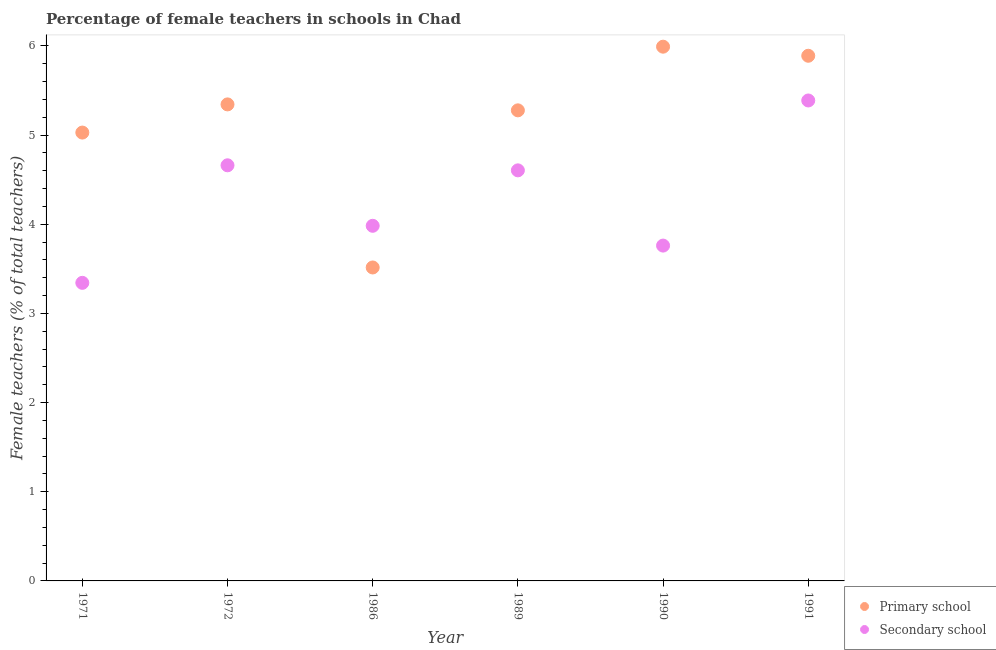How many different coloured dotlines are there?
Provide a succinct answer. 2. Is the number of dotlines equal to the number of legend labels?
Ensure brevity in your answer.  Yes. What is the percentage of female teachers in secondary schools in 1989?
Offer a terse response. 4.6. Across all years, what is the maximum percentage of female teachers in secondary schools?
Make the answer very short. 5.39. Across all years, what is the minimum percentage of female teachers in primary schools?
Provide a short and direct response. 3.52. What is the total percentage of female teachers in primary schools in the graph?
Your answer should be very brief. 31.05. What is the difference between the percentage of female teachers in primary schools in 1986 and that in 1991?
Provide a succinct answer. -2.37. What is the difference between the percentage of female teachers in primary schools in 1990 and the percentage of female teachers in secondary schools in 1986?
Offer a very short reply. 2.01. What is the average percentage of female teachers in primary schools per year?
Ensure brevity in your answer.  5.17. In the year 1991, what is the difference between the percentage of female teachers in primary schools and percentage of female teachers in secondary schools?
Your answer should be very brief. 0.5. What is the ratio of the percentage of female teachers in secondary schools in 1986 to that in 1989?
Provide a short and direct response. 0.86. Is the difference between the percentage of female teachers in primary schools in 1989 and 1990 greater than the difference between the percentage of female teachers in secondary schools in 1989 and 1990?
Keep it short and to the point. No. What is the difference between the highest and the second highest percentage of female teachers in secondary schools?
Offer a terse response. 0.73. What is the difference between the highest and the lowest percentage of female teachers in secondary schools?
Offer a terse response. 2.05. In how many years, is the percentage of female teachers in secondary schools greater than the average percentage of female teachers in secondary schools taken over all years?
Make the answer very short. 3. Is the percentage of female teachers in primary schools strictly greater than the percentage of female teachers in secondary schools over the years?
Offer a terse response. No. Is the percentage of female teachers in secondary schools strictly less than the percentage of female teachers in primary schools over the years?
Offer a very short reply. No. How many years are there in the graph?
Your answer should be compact. 6. What is the difference between two consecutive major ticks on the Y-axis?
Your response must be concise. 1. Does the graph contain any zero values?
Give a very brief answer. No. Does the graph contain grids?
Offer a very short reply. No. How are the legend labels stacked?
Your answer should be very brief. Vertical. What is the title of the graph?
Make the answer very short. Percentage of female teachers in schools in Chad. Does "Secondary school" appear as one of the legend labels in the graph?
Offer a very short reply. Yes. What is the label or title of the X-axis?
Give a very brief answer. Year. What is the label or title of the Y-axis?
Provide a succinct answer. Female teachers (% of total teachers). What is the Female teachers (% of total teachers) in Primary school in 1971?
Provide a succinct answer. 5.03. What is the Female teachers (% of total teachers) in Secondary school in 1971?
Offer a terse response. 3.34. What is the Female teachers (% of total teachers) of Primary school in 1972?
Keep it short and to the point. 5.34. What is the Female teachers (% of total teachers) of Secondary school in 1972?
Your response must be concise. 4.66. What is the Female teachers (% of total teachers) in Primary school in 1986?
Your answer should be very brief. 3.52. What is the Female teachers (% of total teachers) in Secondary school in 1986?
Make the answer very short. 3.98. What is the Female teachers (% of total teachers) of Primary school in 1989?
Keep it short and to the point. 5.28. What is the Female teachers (% of total teachers) of Secondary school in 1989?
Offer a very short reply. 4.6. What is the Female teachers (% of total teachers) of Primary school in 1990?
Offer a terse response. 5.99. What is the Female teachers (% of total teachers) of Secondary school in 1990?
Provide a short and direct response. 3.76. What is the Female teachers (% of total teachers) in Primary school in 1991?
Offer a very short reply. 5.89. What is the Female teachers (% of total teachers) in Secondary school in 1991?
Provide a succinct answer. 5.39. Across all years, what is the maximum Female teachers (% of total teachers) in Primary school?
Keep it short and to the point. 5.99. Across all years, what is the maximum Female teachers (% of total teachers) of Secondary school?
Ensure brevity in your answer.  5.39. Across all years, what is the minimum Female teachers (% of total teachers) in Primary school?
Ensure brevity in your answer.  3.52. Across all years, what is the minimum Female teachers (% of total teachers) of Secondary school?
Keep it short and to the point. 3.34. What is the total Female teachers (% of total teachers) in Primary school in the graph?
Your answer should be compact. 31.05. What is the total Female teachers (% of total teachers) in Secondary school in the graph?
Your answer should be compact. 25.74. What is the difference between the Female teachers (% of total teachers) in Primary school in 1971 and that in 1972?
Offer a very short reply. -0.32. What is the difference between the Female teachers (% of total teachers) in Secondary school in 1971 and that in 1972?
Offer a terse response. -1.32. What is the difference between the Female teachers (% of total teachers) in Primary school in 1971 and that in 1986?
Give a very brief answer. 1.51. What is the difference between the Female teachers (% of total teachers) in Secondary school in 1971 and that in 1986?
Make the answer very short. -0.64. What is the difference between the Female teachers (% of total teachers) of Primary school in 1971 and that in 1989?
Keep it short and to the point. -0.25. What is the difference between the Female teachers (% of total teachers) in Secondary school in 1971 and that in 1989?
Offer a terse response. -1.26. What is the difference between the Female teachers (% of total teachers) of Primary school in 1971 and that in 1990?
Provide a succinct answer. -0.96. What is the difference between the Female teachers (% of total teachers) of Secondary school in 1971 and that in 1990?
Your response must be concise. -0.42. What is the difference between the Female teachers (% of total teachers) in Primary school in 1971 and that in 1991?
Offer a very short reply. -0.86. What is the difference between the Female teachers (% of total teachers) of Secondary school in 1971 and that in 1991?
Make the answer very short. -2.05. What is the difference between the Female teachers (% of total teachers) of Primary school in 1972 and that in 1986?
Make the answer very short. 1.83. What is the difference between the Female teachers (% of total teachers) in Secondary school in 1972 and that in 1986?
Provide a succinct answer. 0.68. What is the difference between the Female teachers (% of total teachers) of Primary school in 1972 and that in 1989?
Offer a very short reply. 0.07. What is the difference between the Female teachers (% of total teachers) of Secondary school in 1972 and that in 1989?
Give a very brief answer. 0.06. What is the difference between the Female teachers (% of total teachers) in Primary school in 1972 and that in 1990?
Provide a succinct answer. -0.65. What is the difference between the Female teachers (% of total teachers) in Secondary school in 1972 and that in 1990?
Offer a very short reply. 0.9. What is the difference between the Female teachers (% of total teachers) in Primary school in 1972 and that in 1991?
Offer a very short reply. -0.55. What is the difference between the Female teachers (% of total teachers) of Secondary school in 1972 and that in 1991?
Ensure brevity in your answer.  -0.73. What is the difference between the Female teachers (% of total teachers) of Primary school in 1986 and that in 1989?
Your response must be concise. -1.76. What is the difference between the Female teachers (% of total teachers) of Secondary school in 1986 and that in 1989?
Your answer should be very brief. -0.62. What is the difference between the Female teachers (% of total teachers) in Primary school in 1986 and that in 1990?
Offer a terse response. -2.48. What is the difference between the Female teachers (% of total teachers) of Secondary school in 1986 and that in 1990?
Your answer should be compact. 0.22. What is the difference between the Female teachers (% of total teachers) in Primary school in 1986 and that in 1991?
Your response must be concise. -2.37. What is the difference between the Female teachers (% of total teachers) of Secondary school in 1986 and that in 1991?
Ensure brevity in your answer.  -1.41. What is the difference between the Female teachers (% of total teachers) of Primary school in 1989 and that in 1990?
Keep it short and to the point. -0.71. What is the difference between the Female teachers (% of total teachers) in Secondary school in 1989 and that in 1990?
Provide a succinct answer. 0.84. What is the difference between the Female teachers (% of total teachers) of Primary school in 1989 and that in 1991?
Keep it short and to the point. -0.61. What is the difference between the Female teachers (% of total teachers) of Secondary school in 1989 and that in 1991?
Provide a short and direct response. -0.78. What is the difference between the Female teachers (% of total teachers) in Primary school in 1990 and that in 1991?
Make the answer very short. 0.1. What is the difference between the Female teachers (% of total teachers) in Secondary school in 1990 and that in 1991?
Offer a terse response. -1.63. What is the difference between the Female teachers (% of total teachers) in Primary school in 1971 and the Female teachers (% of total teachers) in Secondary school in 1972?
Your answer should be compact. 0.37. What is the difference between the Female teachers (% of total teachers) of Primary school in 1971 and the Female teachers (% of total teachers) of Secondary school in 1986?
Your response must be concise. 1.05. What is the difference between the Female teachers (% of total teachers) of Primary school in 1971 and the Female teachers (% of total teachers) of Secondary school in 1989?
Keep it short and to the point. 0.42. What is the difference between the Female teachers (% of total teachers) of Primary school in 1971 and the Female teachers (% of total teachers) of Secondary school in 1990?
Make the answer very short. 1.27. What is the difference between the Female teachers (% of total teachers) in Primary school in 1971 and the Female teachers (% of total teachers) in Secondary school in 1991?
Your answer should be compact. -0.36. What is the difference between the Female teachers (% of total teachers) of Primary school in 1972 and the Female teachers (% of total teachers) of Secondary school in 1986?
Make the answer very short. 1.36. What is the difference between the Female teachers (% of total teachers) of Primary school in 1972 and the Female teachers (% of total teachers) of Secondary school in 1989?
Make the answer very short. 0.74. What is the difference between the Female teachers (% of total teachers) of Primary school in 1972 and the Female teachers (% of total teachers) of Secondary school in 1990?
Keep it short and to the point. 1.58. What is the difference between the Female teachers (% of total teachers) in Primary school in 1972 and the Female teachers (% of total teachers) in Secondary school in 1991?
Your answer should be compact. -0.04. What is the difference between the Female teachers (% of total teachers) in Primary school in 1986 and the Female teachers (% of total teachers) in Secondary school in 1989?
Your response must be concise. -1.09. What is the difference between the Female teachers (% of total teachers) in Primary school in 1986 and the Female teachers (% of total teachers) in Secondary school in 1990?
Provide a short and direct response. -0.25. What is the difference between the Female teachers (% of total teachers) of Primary school in 1986 and the Female teachers (% of total teachers) of Secondary school in 1991?
Your answer should be compact. -1.87. What is the difference between the Female teachers (% of total teachers) of Primary school in 1989 and the Female teachers (% of total teachers) of Secondary school in 1990?
Provide a short and direct response. 1.52. What is the difference between the Female teachers (% of total teachers) in Primary school in 1989 and the Female teachers (% of total teachers) in Secondary school in 1991?
Your answer should be very brief. -0.11. What is the difference between the Female teachers (% of total teachers) in Primary school in 1990 and the Female teachers (% of total teachers) in Secondary school in 1991?
Your response must be concise. 0.6. What is the average Female teachers (% of total teachers) of Primary school per year?
Offer a very short reply. 5.17. What is the average Female teachers (% of total teachers) in Secondary school per year?
Make the answer very short. 4.29. In the year 1971, what is the difference between the Female teachers (% of total teachers) of Primary school and Female teachers (% of total teachers) of Secondary school?
Provide a short and direct response. 1.69. In the year 1972, what is the difference between the Female teachers (% of total teachers) in Primary school and Female teachers (% of total teachers) in Secondary school?
Keep it short and to the point. 0.68. In the year 1986, what is the difference between the Female teachers (% of total teachers) of Primary school and Female teachers (% of total teachers) of Secondary school?
Offer a terse response. -0.47. In the year 1989, what is the difference between the Female teachers (% of total teachers) of Primary school and Female teachers (% of total teachers) of Secondary school?
Your answer should be compact. 0.67. In the year 1990, what is the difference between the Female teachers (% of total teachers) in Primary school and Female teachers (% of total teachers) in Secondary school?
Your answer should be compact. 2.23. In the year 1991, what is the difference between the Female teachers (% of total teachers) in Primary school and Female teachers (% of total teachers) in Secondary school?
Give a very brief answer. 0.5. What is the ratio of the Female teachers (% of total teachers) of Primary school in 1971 to that in 1972?
Offer a very short reply. 0.94. What is the ratio of the Female teachers (% of total teachers) in Secondary school in 1971 to that in 1972?
Your answer should be compact. 0.72. What is the ratio of the Female teachers (% of total teachers) of Primary school in 1971 to that in 1986?
Provide a short and direct response. 1.43. What is the ratio of the Female teachers (% of total teachers) of Secondary school in 1971 to that in 1986?
Offer a very short reply. 0.84. What is the ratio of the Female teachers (% of total teachers) in Primary school in 1971 to that in 1989?
Provide a short and direct response. 0.95. What is the ratio of the Female teachers (% of total teachers) of Secondary school in 1971 to that in 1989?
Keep it short and to the point. 0.73. What is the ratio of the Female teachers (% of total teachers) of Primary school in 1971 to that in 1990?
Your response must be concise. 0.84. What is the ratio of the Female teachers (% of total teachers) in Secondary school in 1971 to that in 1990?
Ensure brevity in your answer.  0.89. What is the ratio of the Female teachers (% of total teachers) of Primary school in 1971 to that in 1991?
Keep it short and to the point. 0.85. What is the ratio of the Female teachers (% of total teachers) of Secondary school in 1971 to that in 1991?
Ensure brevity in your answer.  0.62. What is the ratio of the Female teachers (% of total teachers) of Primary school in 1972 to that in 1986?
Ensure brevity in your answer.  1.52. What is the ratio of the Female teachers (% of total teachers) of Secondary school in 1972 to that in 1986?
Offer a terse response. 1.17. What is the ratio of the Female teachers (% of total teachers) of Primary school in 1972 to that in 1989?
Your answer should be very brief. 1.01. What is the ratio of the Female teachers (% of total teachers) of Secondary school in 1972 to that in 1989?
Offer a very short reply. 1.01. What is the ratio of the Female teachers (% of total teachers) in Primary school in 1972 to that in 1990?
Ensure brevity in your answer.  0.89. What is the ratio of the Female teachers (% of total teachers) in Secondary school in 1972 to that in 1990?
Keep it short and to the point. 1.24. What is the ratio of the Female teachers (% of total teachers) in Primary school in 1972 to that in 1991?
Your answer should be compact. 0.91. What is the ratio of the Female teachers (% of total teachers) in Secondary school in 1972 to that in 1991?
Keep it short and to the point. 0.87. What is the ratio of the Female teachers (% of total teachers) of Primary school in 1986 to that in 1989?
Make the answer very short. 0.67. What is the ratio of the Female teachers (% of total teachers) of Secondary school in 1986 to that in 1989?
Provide a succinct answer. 0.86. What is the ratio of the Female teachers (% of total teachers) in Primary school in 1986 to that in 1990?
Give a very brief answer. 0.59. What is the ratio of the Female teachers (% of total teachers) of Secondary school in 1986 to that in 1990?
Offer a terse response. 1.06. What is the ratio of the Female teachers (% of total teachers) in Primary school in 1986 to that in 1991?
Your answer should be compact. 0.6. What is the ratio of the Female teachers (% of total teachers) of Secondary school in 1986 to that in 1991?
Your answer should be compact. 0.74. What is the ratio of the Female teachers (% of total teachers) in Primary school in 1989 to that in 1990?
Make the answer very short. 0.88. What is the ratio of the Female teachers (% of total teachers) of Secondary school in 1989 to that in 1990?
Offer a terse response. 1.22. What is the ratio of the Female teachers (% of total teachers) of Primary school in 1989 to that in 1991?
Ensure brevity in your answer.  0.9. What is the ratio of the Female teachers (% of total teachers) of Secondary school in 1989 to that in 1991?
Offer a terse response. 0.85. What is the ratio of the Female teachers (% of total teachers) in Primary school in 1990 to that in 1991?
Your response must be concise. 1.02. What is the ratio of the Female teachers (% of total teachers) of Secondary school in 1990 to that in 1991?
Keep it short and to the point. 0.7. What is the difference between the highest and the second highest Female teachers (% of total teachers) of Primary school?
Offer a terse response. 0.1. What is the difference between the highest and the second highest Female teachers (% of total teachers) of Secondary school?
Offer a very short reply. 0.73. What is the difference between the highest and the lowest Female teachers (% of total teachers) in Primary school?
Give a very brief answer. 2.48. What is the difference between the highest and the lowest Female teachers (% of total teachers) of Secondary school?
Ensure brevity in your answer.  2.05. 